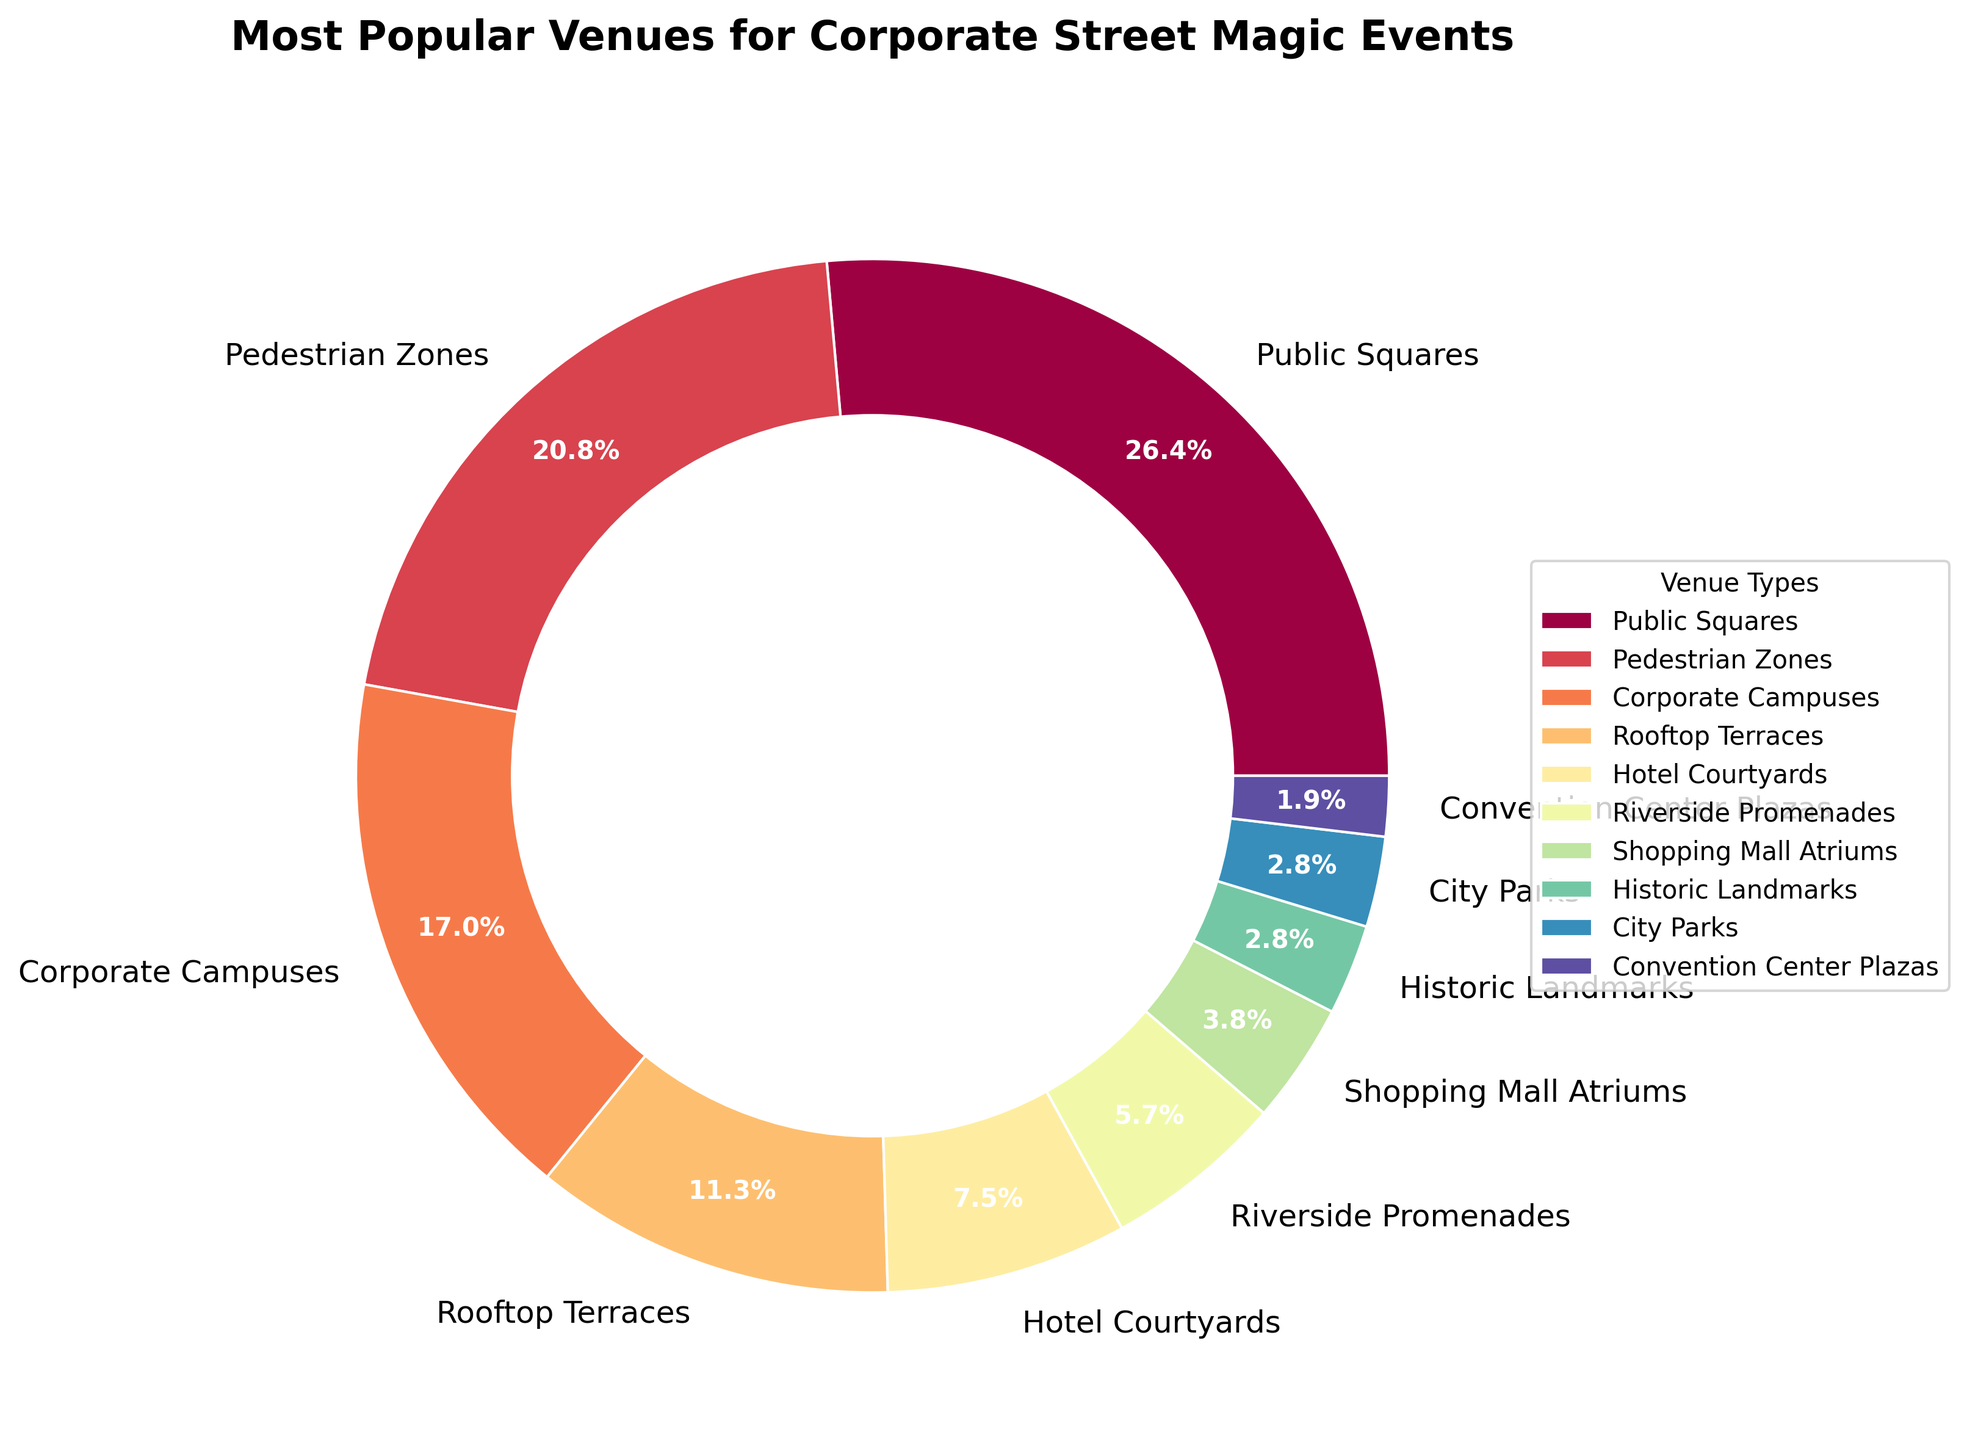Which venue type is chosen the most for corporate street magic events? The largest slice in the pie chart represents Public Squares, which indicates that they have the highest percentage.
Answer: Public Squares What percentage of corporate street magic events are held in Rooftop Terraces? The slice for Rooftop Terraces is labeled with 12%, which represents their percentage.
Answer: 12% How much more popular are Public Squares compared to Hotel Courtyards for corporate street magic events? Public Squares have a percentage of 28% while Hotel Courtyards have 8%. The difference is 28% - 8%.
Answer: 20% What is the combined percentage of corporate street magic events held in Riverside Promenades and Shopping Mall Atriums? Riverside Promenades account for 6% and Shopping Mall Atriums for 4%. Adding these gives 6% + 4%.
Answer: 10% Which venue types have equal popularity for corporate street magic events? Historic Landmarks and City Parks both have slices representing 3%, indicating they are equally popular.
Answer: Historic Landmarks and City Parks What is the least popular venue type for corporate street magic events? The smallest slice in the pie chart represents Convention Center Plazas, which have the smallest percentage.
Answer: Convention Center Plazas How do the combined percentages of Corporate Campuses and Pedestrian Zones compare to Public Squares? Corporate Campuses is 18% and Pedestrian Zones is 22%, sum them to get 40%. Compare this to Public Squares at 28%.
Answer: Combined (40%) is greater than Public Squares (28%) Which venue type has 3% of corporate street magic events and what is its visual representation in the chart? Both Historic Landmarks and City Parks account for 3%. Their slices are smaller compared to most other venue types but equal to each other.
Answer: Historic Landmarks and City Parks, small slices How many venue types have a percentage greater than 10% for corporate street magic events? The slices for Public Squares (28%), Pedestrian Zones (22%), Corporate Campuses (18%), and Rooftop Terraces (12%) are all greater than 10%.
Answer: 4 If we combine the percentages of the three least popular venue types, what is the total percentage, and which venue types are they? The least popular venue types are Convention Center Plazas (2%), Historic Landmarks (3%), and City Parks (3%). Summing these gives 2% + 3% + 3%.
Answer: 8%, Convention Center Plazas, Historic Landmarks, and City Parks 